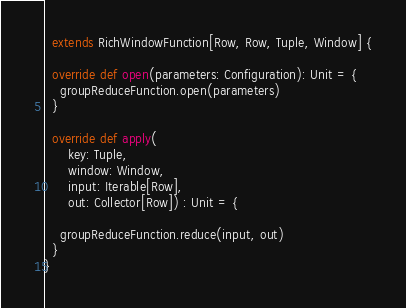Convert code to text. <code><loc_0><loc_0><loc_500><loc_500><_Scala_>  extends RichWindowFunction[Row, Row, Tuple, Window] {

  override def open(parameters: Configuration): Unit = {
    groupReduceFunction.open(parameters)
  }

  override def apply(
      key: Tuple,
      window: Window,
      input: Iterable[Row],
      out: Collector[Row]) : Unit = {

    groupReduceFunction.reduce(input, out)
  }
}
</code> 